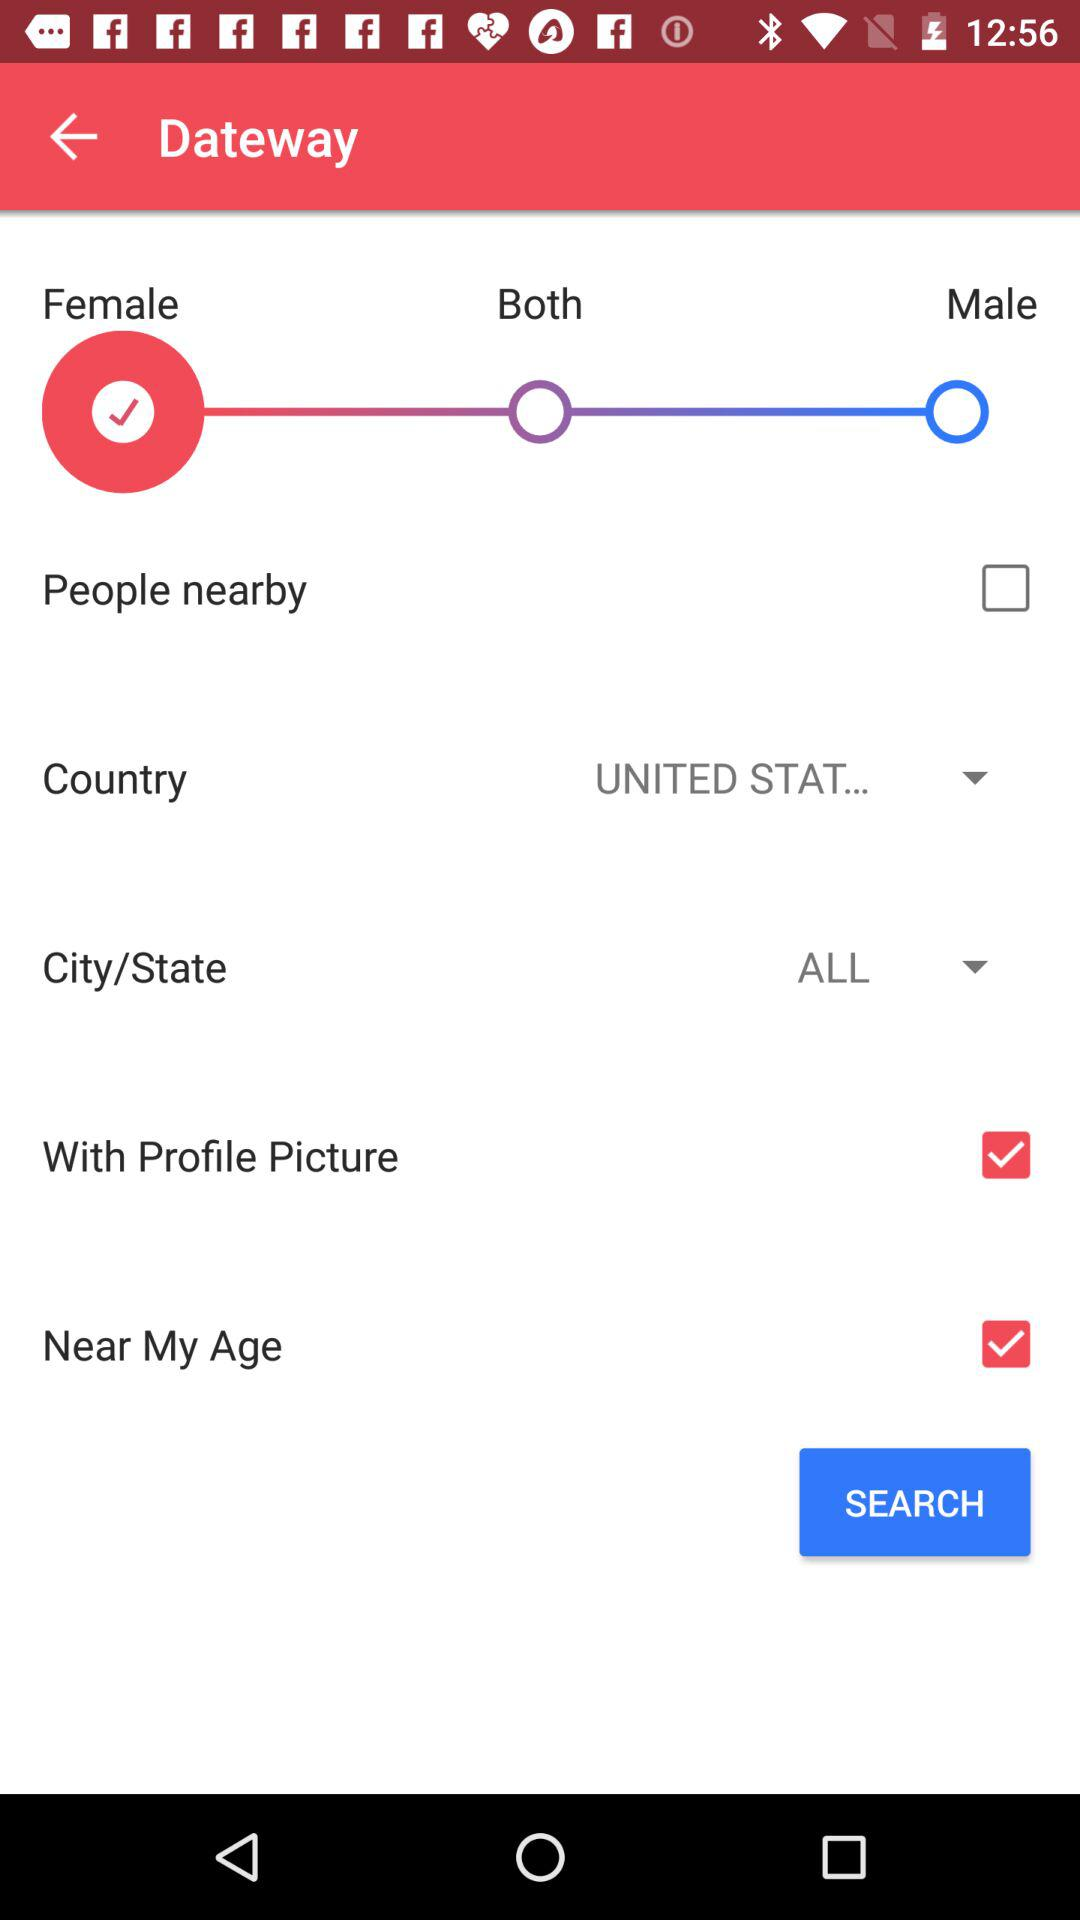What is the status of "With Profile Picture"? The status is "on". 